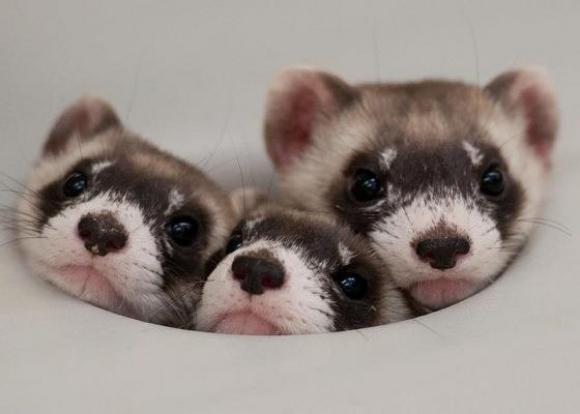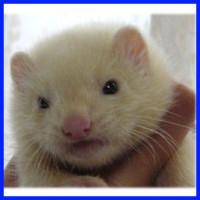The first image is the image on the left, the second image is the image on the right. Evaluate the accuracy of this statement regarding the images: "In one of the images there is one animal being held.". Is it true? Answer yes or no. Yes. The first image is the image on the left, the second image is the image on the right. Examine the images to the left and right. Is the description "The combined images contain four ferrets, at least three ferrets have raccoon-mask markings, and a human hand is grasping at least one ferret." accurate? Answer yes or no. Yes. 